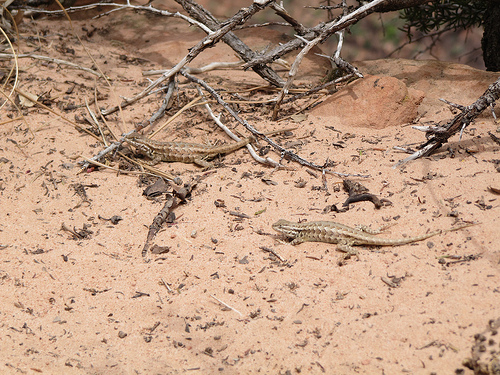<image>
Is the lizard on the sand? Yes. Looking at the image, I can see the lizard is positioned on top of the sand, with the sand providing support. 